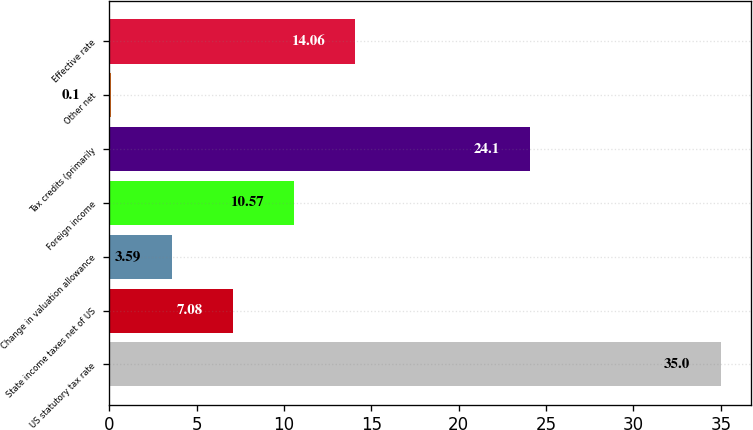Convert chart to OTSL. <chart><loc_0><loc_0><loc_500><loc_500><bar_chart><fcel>US statutory tax rate<fcel>State income taxes net of US<fcel>Change in valuation allowance<fcel>Foreign income<fcel>Tax credits (primarily<fcel>Other net<fcel>Effective rate<nl><fcel>35<fcel>7.08<fcel>3.59<fcel>10.57<fcel>24.1<fcel>0.1<fcel>14.06<nl></chart> 